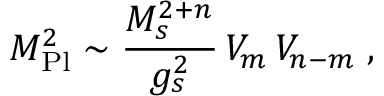<formula> <loc_0><loc_0><loc_500><loc_500>M _ { P l } ^ { 2 } \sim \frac { M _ { s } ^ { 2 + n } } { g _ { s } ^ { 2 } } \, V _ { m } \, V _ { n - m } \, ,</formula> 